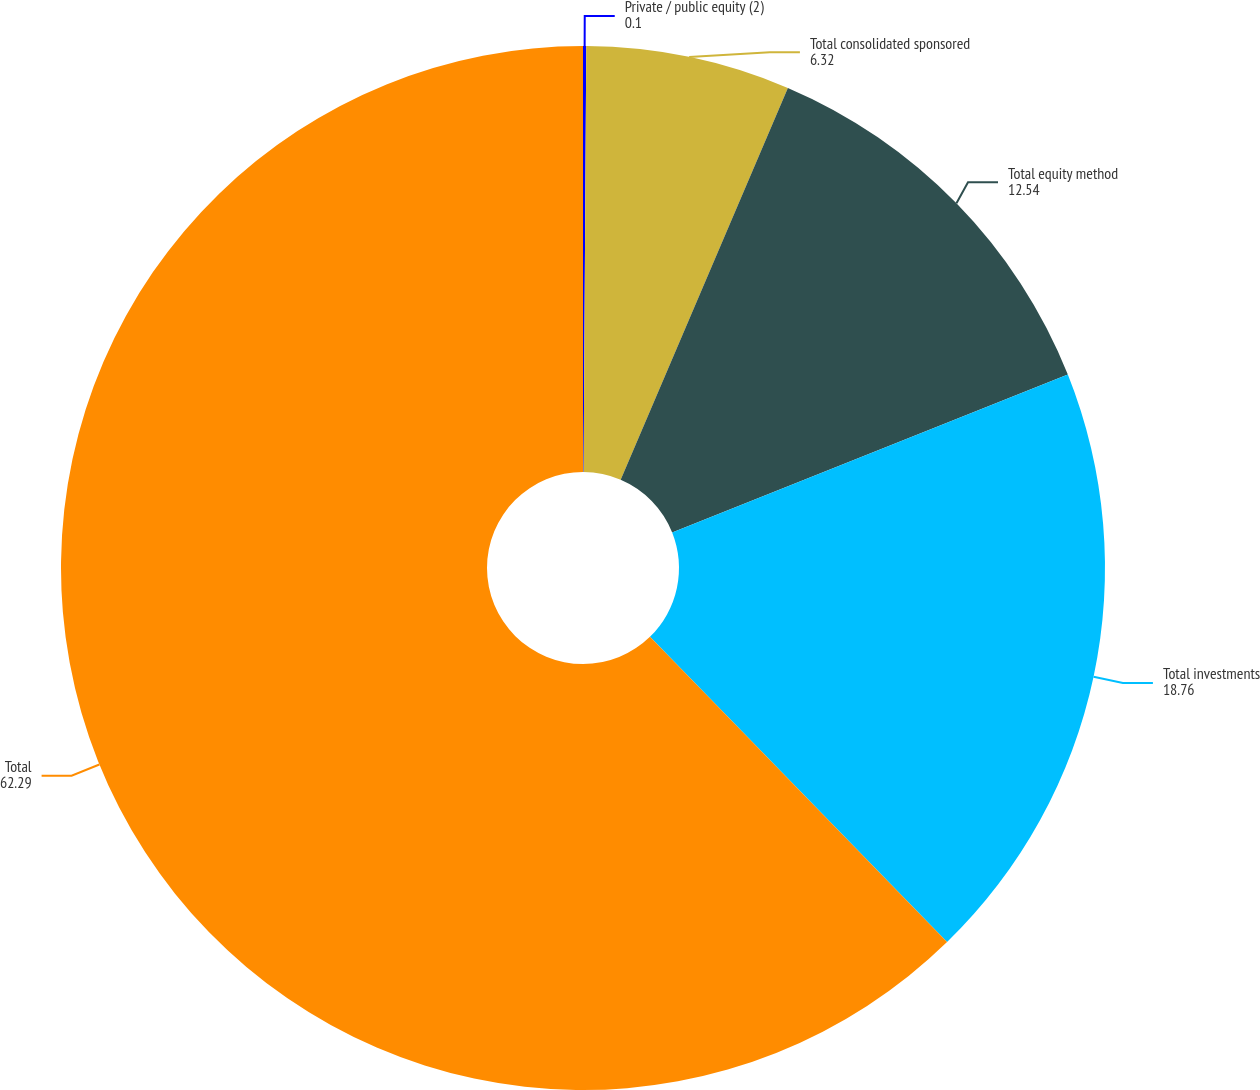Convert chart to OTSL. <chart><loc_0><loc_0><loc_500><loc_500><pie_chart><fcel>Private / public equity (2)<fcel>Total consolidated sponsored<fcel>Total equity method<fcel>Total investments<fcel>Total<nl><fcel>0.1%<fcel>6.32%<fcel>12.54%<fcel>18.76%<fcel>62.29%<nl></chart> 